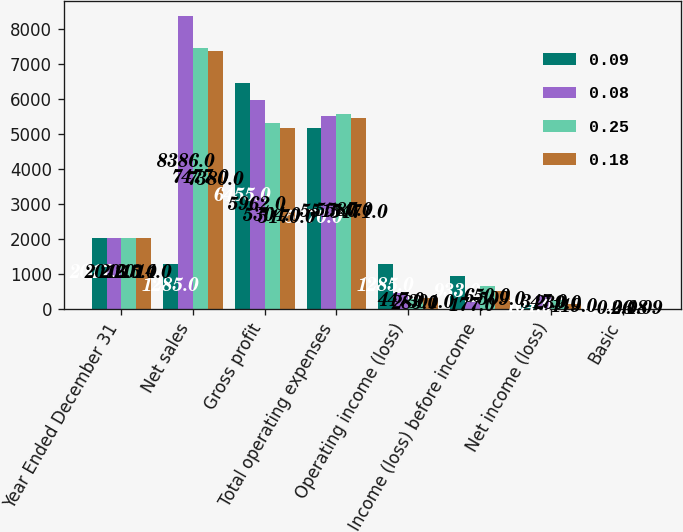<chart> <loc_0><loc_0><loc_500><loc_500><stacked_bar_chart><ecel><fcel>Year Ended December 31<fcel>Net sales<fcel>Gross profit<fcel>Total operating expenses<fcel>Operating income (loss)<fcel>Income (loss) before income<fcel>Net income (loss)<fcel>Basic<nl><fcel>0.09<fcel>2017<fcel>1285<fcel>6455<fcel>5170<fcel>1285<fcel>933<fcel>104<fcel>0.08<nl><fcel>0.08<fcel>2016<fcel>8386<fcel>5962<fcel>5515<fcel>447<fcel>177<fcel>347<fcel>0.26<nl><fcel>0.25<fcel>2015<fcel>7477<fcel>5304<fcel>5587<fcel>283<fcel>650<fcel>239<fcel>0.18<nl><fcel>0.18<fcel>2014<fcel>7380<fcel>5170<fcel>5471<fcel>301<fcel>509<fcel>119<fcel>0.09<nl></chart> 